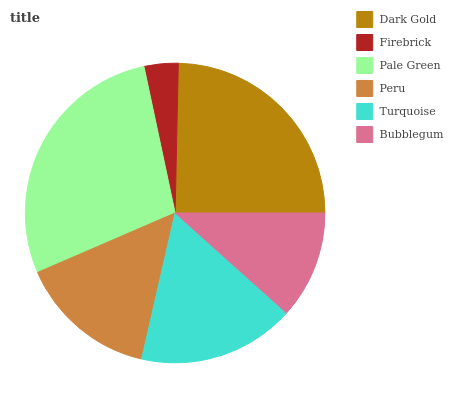Is Firebrick the minimum?
Answer yes or no. Yes. Is Pale Green the maximum?
Answer yes or no. Yes. Is Pale Green the minimum?
Answer yes or no. No. Is Firebrick the maximum?
Answer yes or no. No. Is Pale Green greater than Firebrick?
Answer yes or no. Yes. Is Firebrick less than Pale Green?
Answer yes or no. Yes. Is Firebrick greater than Pale Green?
Answer yes or no. No. Is Pale Green less than Firebrick?
Answer yes or no. No. Is Turquoise the high median?
Answer yes or no. Yes. Is Peru the low median?
Answer yes or no. Yes. Is Dark Gold the high median?
Answer yes or no. No. Is Pale Green the low median?
Answer yes or no. No. 